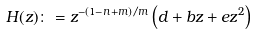<formula> <loc_0><loc_0><loc_500><loc_500>H ( z ) \colon = z ^ { - ( 1 - n + m ) / m } \left ( d + b z + e z ^ { 2 } \right )</formula> 